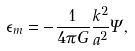Convert formula to latex. <formula><loc_0><loc_0><loc_500><loc_500>\epsilon _ { m } = - \frac { 1 } { 4 \pi G } \frac { k ^ { 2 } } { a ^ { 2 } } \Psi ,</formula> 